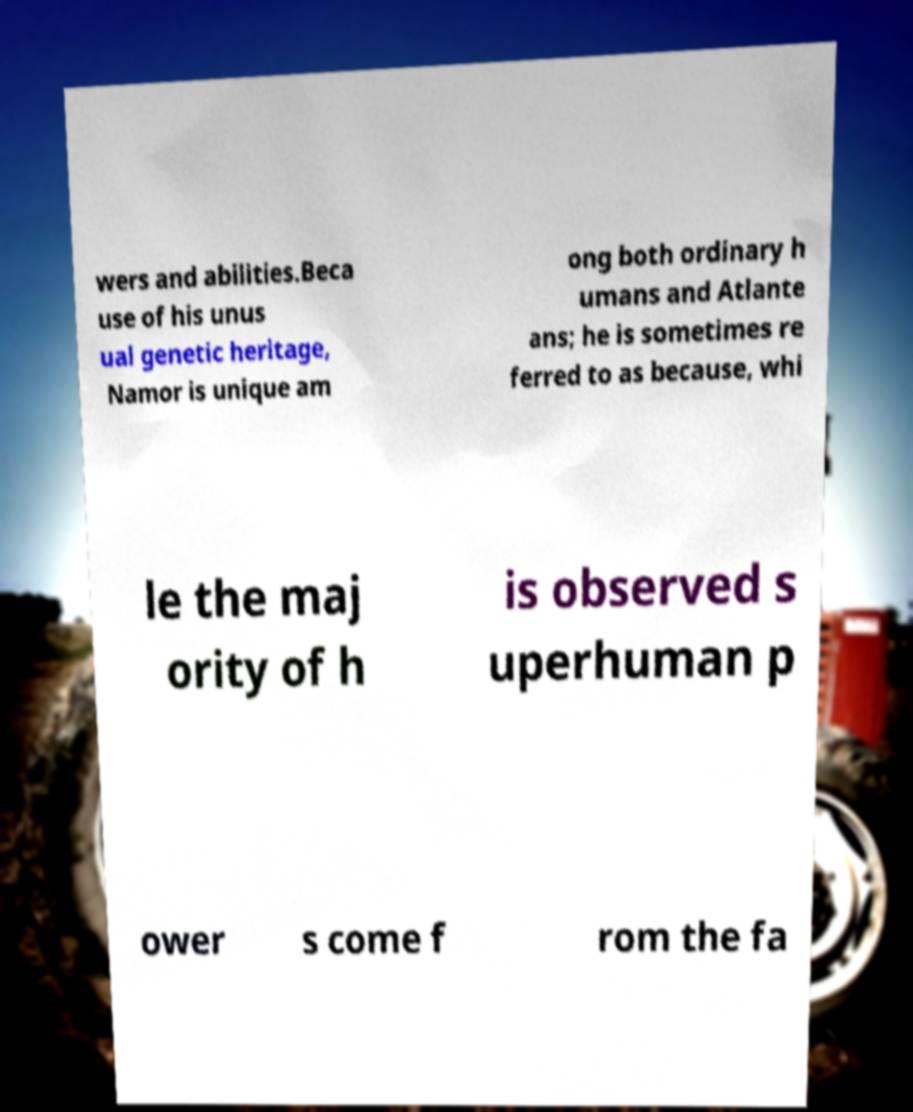For documentation purposes, I need the text within this image transcribed. Could you provide that? wers and abilities.Beca use of his unus ual genetic heritage, Namor is unique am ong both ordinary h umans and Atlante ans; he is sometimes re ferred to as because, whi le the maj ority of h is observed s uperhuman p ower s come f rom the fa 